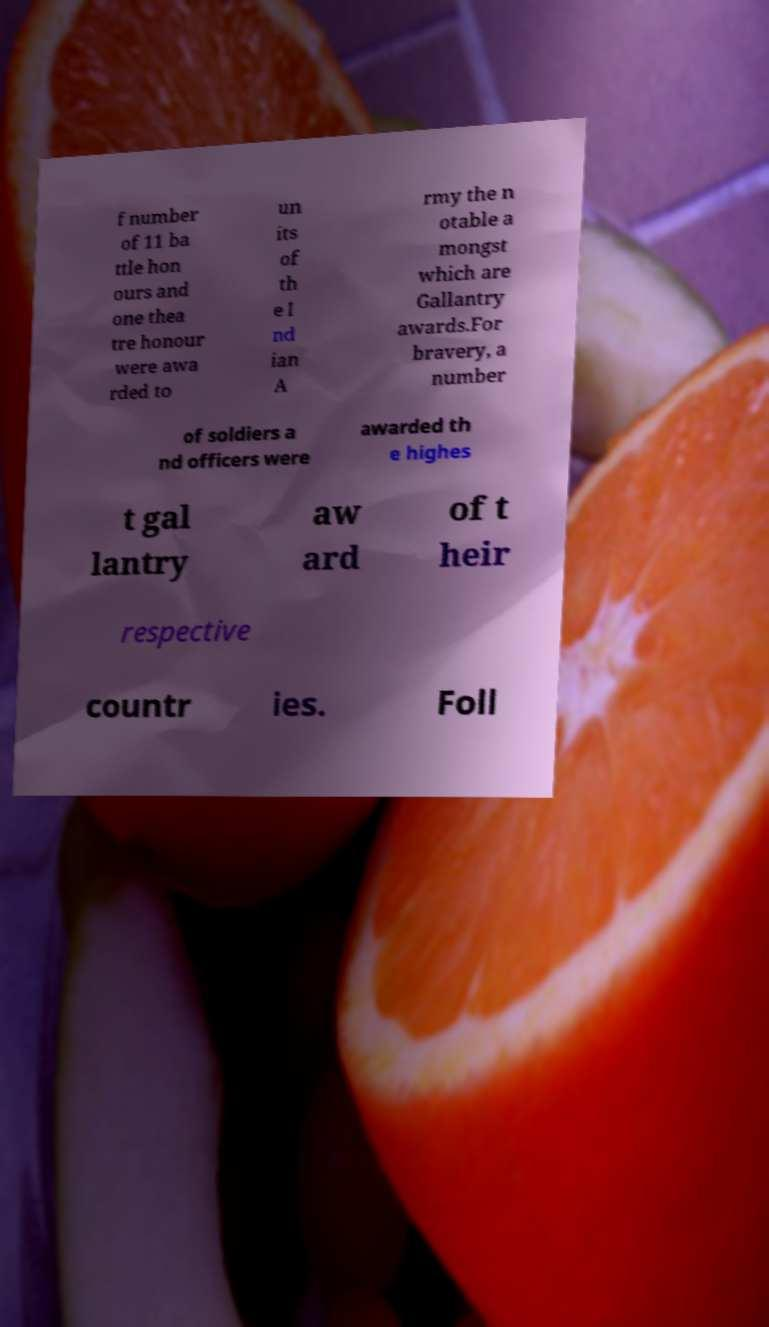Could you assist in decoding the text presented in this image and type it out clearly? f number of 11 ba ttle hon ours and one thea tre honour were awa rded to un its of th e I nd ian A rmy the n otable a mongst which are Gallantry awards.For bravery, a number of soldiers a nd officers were awarded th e highes t gal lantry aw ard of t heir respective countr ies. Foll 